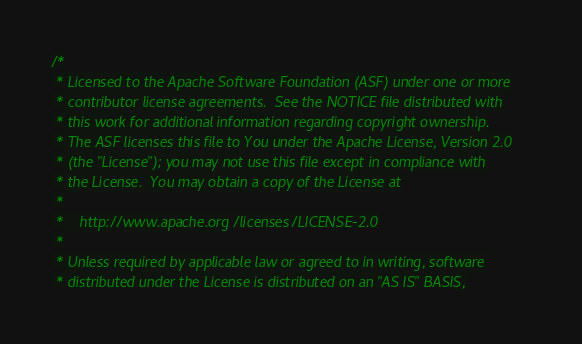Convert code to text. <code><loc_0><loc_0><loc_500><loc_500><_Scala_>/*
 * Licensed to the Apache Software Foundation (ASF) under one or more
 * contributor license agreements.  See the NOTICE file distributed with
 * this work for additional information regarding copyright ownership.
 * The ASF licenses this file to You under the Apache License, Version 2.0
 * (the "License"); you may not use this file except in compliance with
 * the License.  You may obtain a copy of the License at
 *
 *    http://www.apache.org/licenses/LICENSE-2.0
 *
 * Unless required by applicable law or agreed to in writing, software
 * distributed under the License is distributed on an "AS IS" BASIS,</code> 